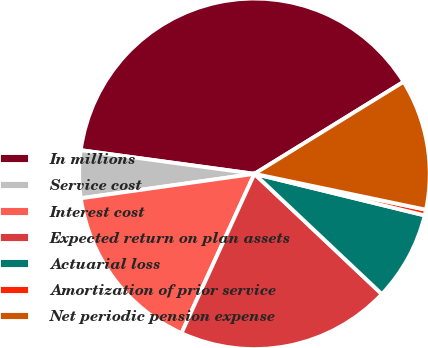Convert chart. <chart><loc_0><loc_0><loc_500><loc_500><pie_chart><fcel>In millions<fcel>Service cost<fcel>Interest cost<fcel>Expected return on plan assets<fcel>Actuarial loss<fcel>Amortization of prior service<fcel>Net periodic pension expense<nl><fcel>39.05%<fcel>4.38%<fcel>15.94%<fcel>19.79%<fcel>8.23%<fcel>0.53%<fcel>12.08%<nl></chart> 